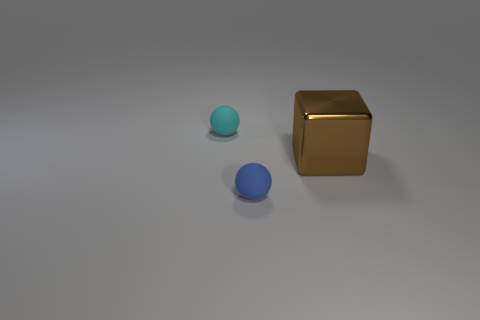How many metal blocks have the same size as the brown metallic thing?
Provide a succinct answer. 0. How many tiny things are either cyan matte spheres or matte spheres?
Your answer should be compact. 2. Are there any large blue metal cubes?
Make the answer very short. No. Is the number of big shiny cubes in front of the large metal cube greater than the number of small cyan rubber spheres left of the cyan object?
Give a very brief answer. No. The rubber ball in front of the thing that is left of the tiny blue rubber ball is what color?
Offer a very short reply. Blue. Are there any large metallic things that have the same color as the shiny block?
Provide a succinct answer. No. There is a ball behind the block that is behind the small sphere that is right of the tiny cyan rubber thing; what size is it?
Give a very brief answer. Small. What is the shape of the blue thing?
Your response must be concise. Sphere. There is a large brown metal object that is right of the tiny cyan matte ball; how many matte balls are in front of it?
Ensure brevity in your answer.  1. How many other objects are there of the same material as the tiny blue ball?
Offer a terse response. 1. 